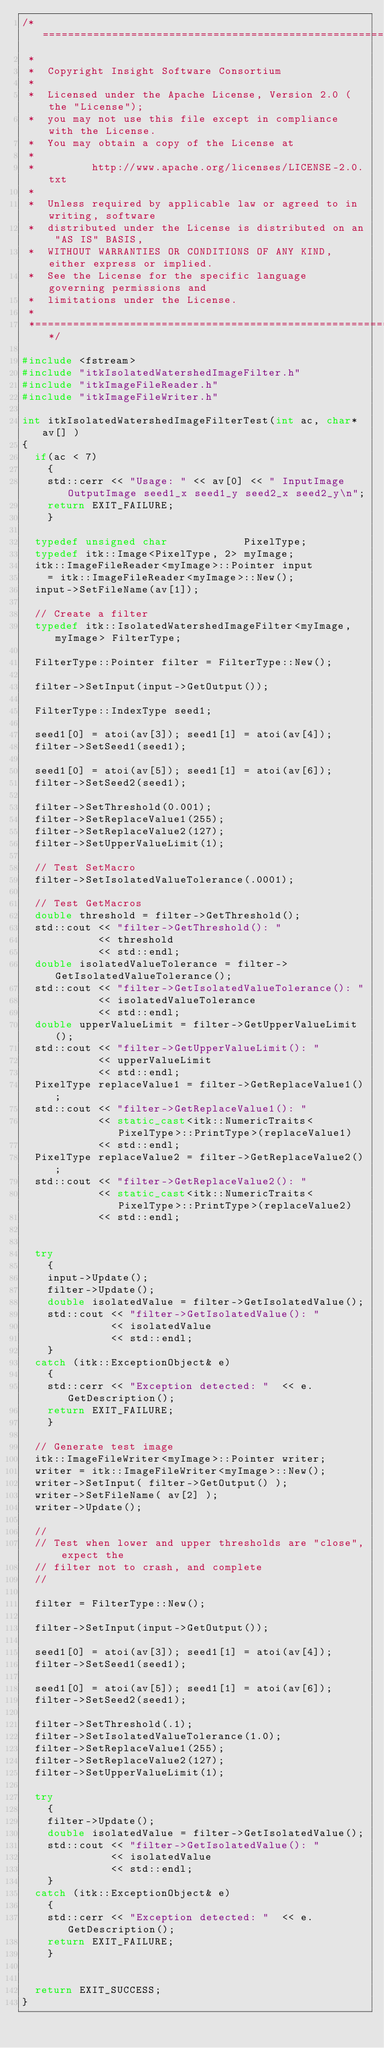<code> <loc_0><loc_0><loc_500><loc_500><_C++_>/*=========================================================================
 *
 *  Copyright Insight Software Consortium
 *
 *  Licensed under the Apache License, Version 2.0 (the "License");
 *  you may not use this file except in compliance with the License.
 *  You may obtain a copy of the License at
 *
 *         http://www.apache.org/licenses/LICENSE-2.0.txt
 *
 *  Unless required by applicable law or agreed to in writing, software
 *  distributed under the License is distributed on an "AS IS" BASIS,
 *  WITHOUT WARRANTIES OR CONDITIONS OF ANY KIND, either express or implied.
 *  See the License for the specific language governing permissions and
 *  limitations under the License.
 *
 *=========================================================================*/

#include <fstream>
#include "itkIsolatedWatershedImageFilter.h"
#include "itkImageFileReader.h"
#include "itkImageFileWriter.h"

int itkIsolatedWatershedImageFilterTest(int ac, char* av[] )
{
  if(ac < 7)
    {
    std::cerr << "Usage: " << av[0] << " InputImage OutputImage seed1_x seed1_y seed2_x seed2_y\n";
    return EXIT_FAILURE;
    }

  typedef unsigned char            PixelType;
  typedef itk::Image<PixelType, 2> myImage;
  itk::ImageFileReader<myImage>::Pointer input
    = itk::ImageFileReader<myImage>::New();
  input->SetFileName(av[1]);

  // Create a filter
  typedef itk::IsolatedWatershedImageFilter<myImage,myImage> FilterType;

  FilterType::Pointer filter = FilterType::New();

  filter->SetInput(input->GetOutput());

  FilterType::IndexType seed1;

  seed1[0] = atoi(av[3]); seed1[1] = atoi(av[4]);
  filter->SetSeed1(seed1);

  seed1[0] = atoi(av[5]); seed1[1] = atoi(av[6]);
  filter->SetSeed2(seed1);

  filter->SetThreshold(0.001);
  filter->SetReplaceValue1(255);
  filter->SetReplaceValue2(127);
  filter->SetUpperValueLimit(1);

  // Test SetMacro
  filter->SetIsolatedValueTolerance(.0001);

  // Test GetMacros
  double threshold = filter->GetThreshold();
  std::cout << "filter->GetThreshold(): "
            << threshold
            << std::endl;
  double isolatedValueTolerance = filter->GetIsolatedValueTolerance();
  std::cout << "filter->GetIsolatedValueTolerance(): "
            << isolatedValueTolerance
            << std::endl;
  double upperValueLimit = filter->GetUpperValueLimit();
  std::cout << "filter->GetUpperValueLimit(): "
            << upperValueLimit
            << std::endl;
  PixelType replaceValue1 = filter->GetReplaceValue1();
  std::cout << "filter->GetReplaceValue1(): "
            << static_cast<itk::NumericTraits<PixelType>::PrintType>(replaceValue1)
            << std::endl;
  PixelType replaceValue2 = filter->GetReplaceValue2();
  std::cout << "filter->GetReplaceValue2(): "
            << static_cast<itk::NumericTraits<PixelType>::PrintType>(replaceValue2)
            << std::endl;


  try
    {
    input->Update();
    filter->Update();
    double isolatedValue = filter->GetIsolatedValue();
    std::cout << "filter->GetIsolatedValue(): "
              << isolatedValue
              << std::endl;
    }
  catch (itk::ExceptionObject& e)
    {
    std::cerr << "Exception detected: "  << e.GetDescription();
    return EXIT_FAILURE;
    }

  // Generate test image
  itk::ImageFileWriter<myImage>::Pointer writer;
  writer = itk::ImageFileWriter<myImage>::New();
  writer->SetInput( filter->GetOutput() );
  writer->SetFileName( av[2] );
  writer->Update();

  //
  // Test when lower and upper thresholds are "close", expect the
  // filter not to crash, and complete
  //

  filter = FilterType::New();

  filter->SetInput(input->GetOutput());

  seed1[0] = atoi(av[3]); seed1[1] = atoi(av[4]);
  filter->SetSeed1(seed1);

  seed1[0] = atoi(av[5]); seed1[1] = atoi(av[6]);
  filter->SetSeed2(seed1);

  filter->SetThreshold(.1);
  filter->SetIsolatedValueTolerance(1.0);
  filter->SetReplaceValue1(255);
  filter->SetReplaceValue2(127);
  filter->SetUpperValueLimit(1);

  try
    {
    filter->Update();
    double isolatedValue = filter->GetIsolatedValue();
    std::cout << "filter->GetIsolatedValue(): "
              << isolatedValue
              << std::endl;
    }
  catch (itk::ExceptionObject& e)
    {
    std::cerr << "Exception detected: "  << e.GetDescription();
    return EXIT_FAILURE;
    }


  return EXIT_SUCCESS;
}
</code> 